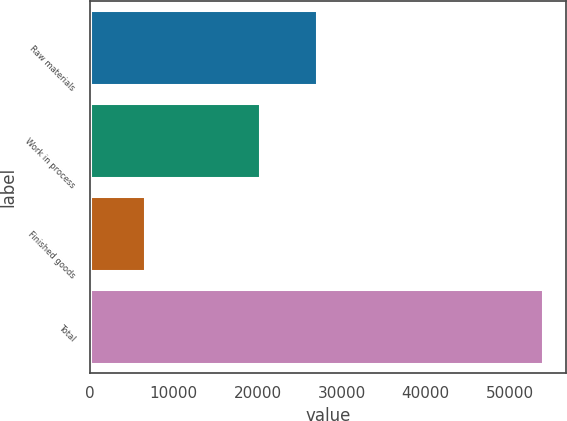Convert chart. <chart><loc_0><loc_0><loc_500><loc_500><bar_chart><fcel>Raw materials<fcel>Work in process<fcel>Finished goods<fcel>Total<nl><fcel>27098<fcel>20321<fcel>6561<fcel>53980<nl></chart> 